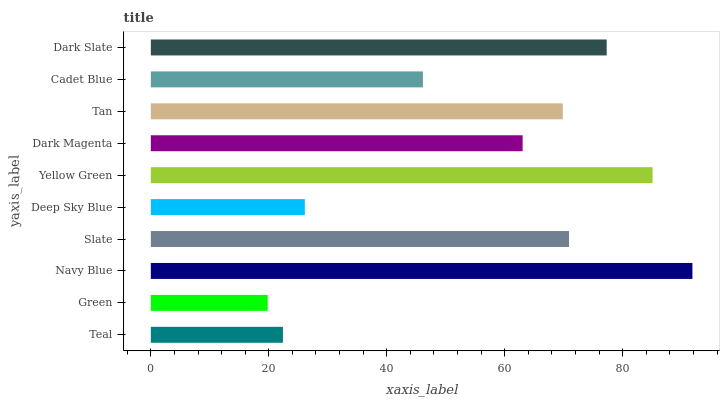Is Green the minimum?
Answer yes or no. Yes. Is Navy Blue the maximum?
Answer yes or no. Yes. Is Navy Blue the minimum?
Answer yes or no. No. Is Green the maximum?
Answer yes or no. No. Is Navy Blue greater than Green?
Answer yes or no. Yes. Is Green less than Navy Blue?
Answer yes or no. Yes. Is Green greater than Navy Blue?
Answer yes or no. No. Is Navy Blue less than Green?
Answer yes or no. No. Is Tan the high median?
Answer yes or no. Yes. Is Dark Magenta the low median?
Answer yes or no. Yes. Is Slate the high median?
Answer yes or no. No. Is Cadet Blue the low median?
Answer yes or no. No. 